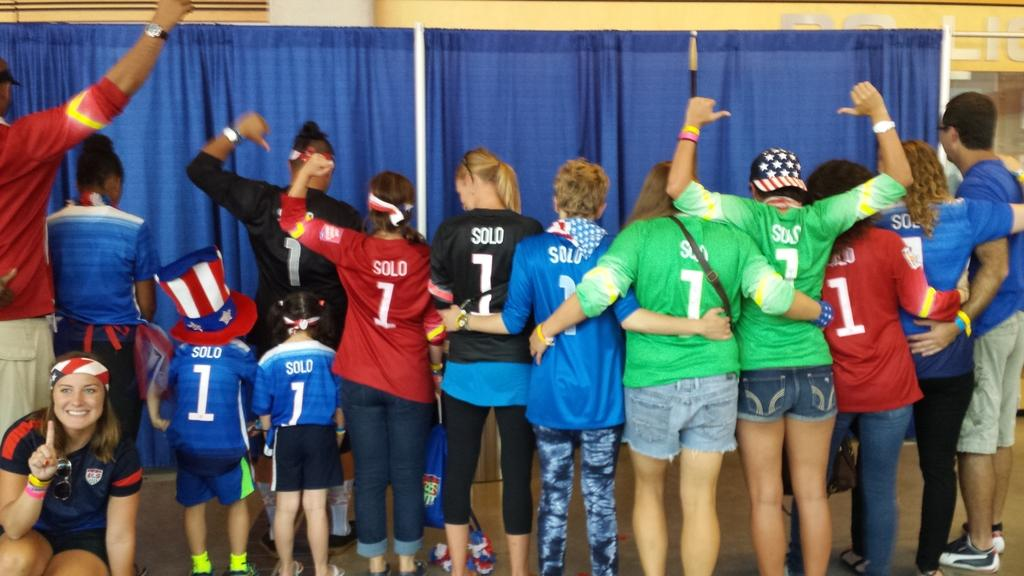Provide a one-sentence caption for the provided image. A row of people, adults and children, male and female, are lined up facing back, all wearing jerseys with the number one on them. 